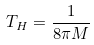Convert formula to latex. <formula><loc_0><loc_0><loc_500><loc_500>T _ { H } = \frac { 1 } { 8 \pi M }</formula> 